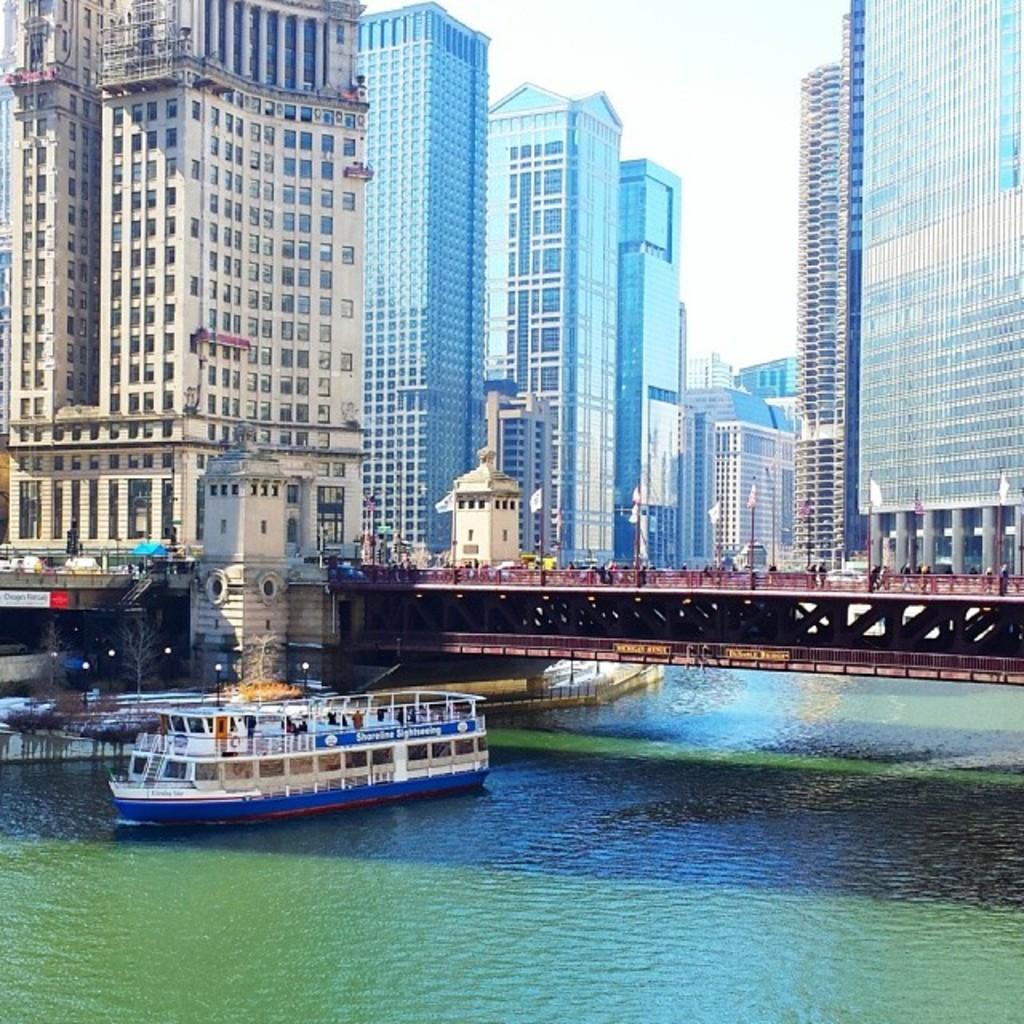In one or two sentences, can you explain what this image depicts? On the left side, there is a boat on the water. Above this boat, there is a bridge. In the background, there are buildings and there are clouds in the sky. 